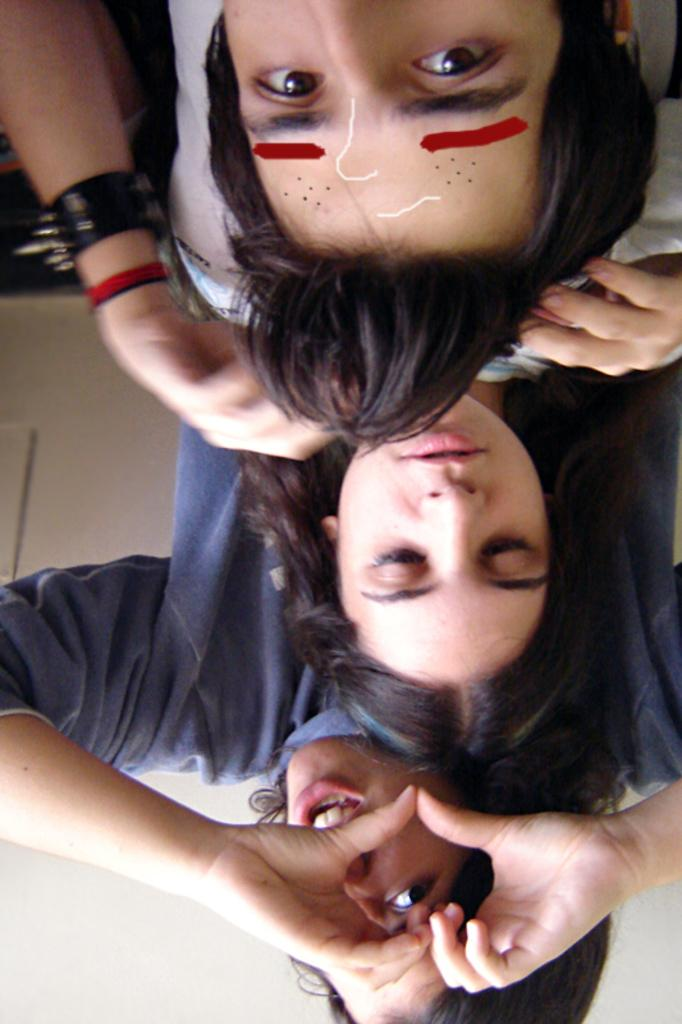How many people are in the image? There are three people in the image. Can you describe the arrangement of the people in the image? The people are sitting one behind the other. What design is featured on the ticket held by one of the people in the image? There is no ticket present in the image, so it is not possible to answer that question. 